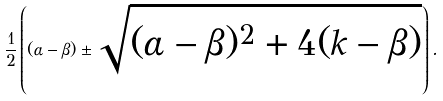<formula> <loc_0><loc_0><loc_500><loc_500>\frac { 1 } { 2 } \left ( ( \alpha - \beta ) \pm \sqrt { ( \alpha - \beta ) ^ { 2 } + 4 ( k - \beta ) } \right ) .</formula> 